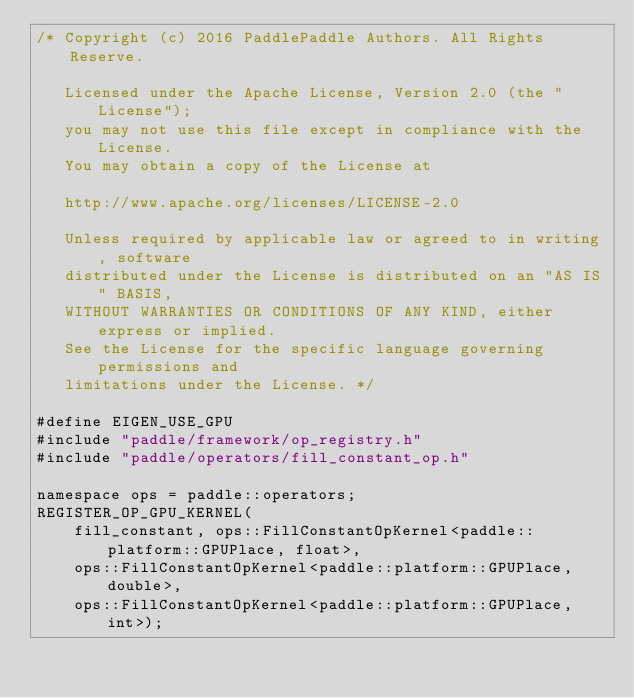Convert code to text. <code><loc_0><loc_0><loc_500><loc_500><_Cuda_>/* Copyright (c) 2016 PaddlePaddle Authors. All Rights Reserve.

   Licensed under the Apache License, Version 2.0 (the "License");
   you may not use this file except in compliance with the License.
   You may obtain a copy of the License at

   http://www.apache.org/licenses/LICENSE-2.0

   Unless required by applicable law or agreed to in writing, software
   distributed under the License is distributed on an "AS IS" BASIS,
   WITHOUT WARRANTIES OR CONDITIONS OF ANY KIND, either express or implied.
   See the License for the specific language governing permissions and
   limitations under the License. */

#define EIGEN_USE_GPU
#include "paddle/framework/op_registry.h"
#include "paddle/operators/fill_constant_op.h"

namespace ops = paddle::operators;
REGISTER_OP_GPU_KERNEL(
    fill_constant, ops::FillConstantOpKernel<paddle::platform::GPUPlace, float>,
    ops::FillConstantOpKernel<paddle::platform::GPUPlace, double>,
    ops::FillConstantOpKernel<paddle::platform::GPUPlace, int>);
</code> 